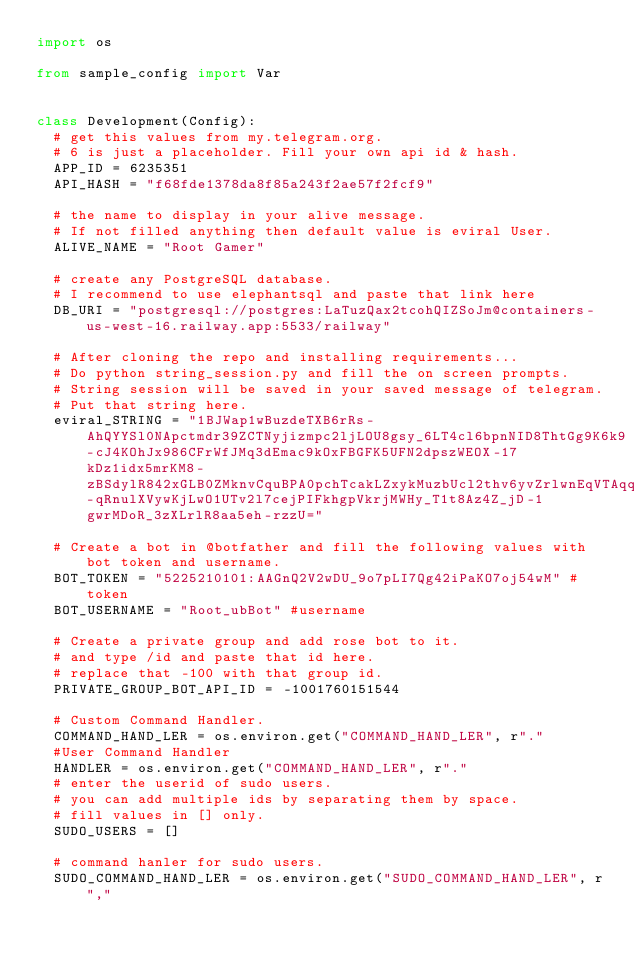<code> <loc_0><loc_0><loc_500><loc_500><_Python_>import os

from sample_config import Var


class Development(Config):
  # get this values from my.telegram.org. 
  # 6 is just a placeholder. Fill your own api id & hash.
  APP_ID = 6235351
  API_HASH = "f68fde1378da8f85a243f2ae57f2fcf9"

  # the name to display in your alive message.
  # If not filled anything then default value is eviral User.
  ALIVE_NAME = "Root Gamer"

  # create any PostgreSQL database.
  # I recommend to use elephantsql and paste that link here
  DB_URI = "postgresql://postgres:LaTuzQax2tcohQIZSoJm@containers-us-west-16.railway.app:5533/railway"

  # After cloning the repo and installing requirements...
  # Do python string_session.py and fill the on screen prompts.
  # String session will be saved in your saved message of telegram.
  # Put that string here.
  eviral_STRING = "1BJWap1wBuzdeTXB6rRs-AhQYYSl0NApctmdr39ZCTNyjizmpc2ljLOU8gsy_6LT4cl6bpnNID8ThtGg9K6k9-cJ4KOhJx986CFrWfJMq3dEmac9kOxFBGFK5UFN2dpszWEOX-17kDz1idx5mrKM8-zBSdylR842xGLB0ZMknvCquBPA0pchTcakLZxykMuzbUcl2thv6yvZrlwnEqVTAqqiqWSCslKdnyREQEO8QOw41y2UaCmajx4yK9dl1pbVrX7NtrKV_Nzb0Xad-qRnulXVywKjLwO1UTv2l7cejPIFkhgpVkrjMWHy_T1t8Az4Z_jD-1gwrMDoR_3zXLrlR8aa5eh-rzzU="

  # Create a bot in @botfather and fill the following values with bot token and username.
  BOT_TOKEN = "5225210101:AAGnQ2V2wDU_9o7pLI7Qg42iPaKO7oj54wM" #token
  BOT_USERNAME = "Root_ubBot" #username

  # Create a private group and add rose bot to it.
  # and type /id and paste that id here.
  # replace that -100 with that group id.
  PRIVATE_GROUP_BOT_API_ID = -1001760151544

  # Custom Command Handler. 
  COMMAND_HAND_LER = os.environ.get("COMMAND_HAND_LER", r"."
  #User Command Handler
  HANDLER = os.environ.get("COMMAND_HAND_LER", r"."
  # enter the userid of sudo users.
  # you can add multiple ids by separating them by space.
  # fill values in [] only.
  SUDO_USERS = []

  # command hanler for sudo users.
  SUDO_COMMAND_HAND_LER = os.environ.get("SUDO_COMMAND_HAND_LER", r","
</code> 